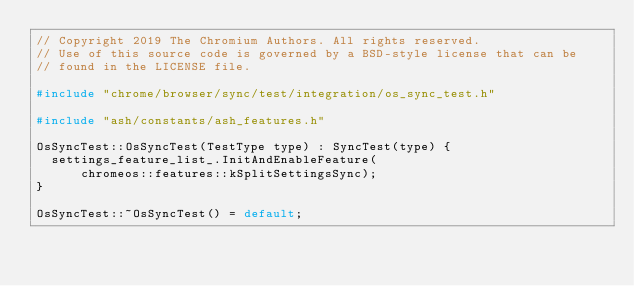<code> <loc_0><loc_0><loc_500><loc_500><_C++_>// Copyright 2019 The Chromium Authors. All rights reserved.
// Use of this source code is governed by a BSD-style license that can be
// found in the LICENSE file.

#include "chrome/browser/sync/test/integration/os_sync_test.h"

#include "ash/constants/ash_features.h"

OsSyncTest::OsSyncTest(TestType type) : SyncTest(type) {
  settings_feature_list_.InitAndEnableFeature(
      chromeos::features::kSplitSettingsSync);
}

OsSyncTest::~OsSyncTest() = default;
</code> 